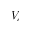<formula> <loc_0><loc_0><loc_500><loc_500>V _ { c }</formula> 